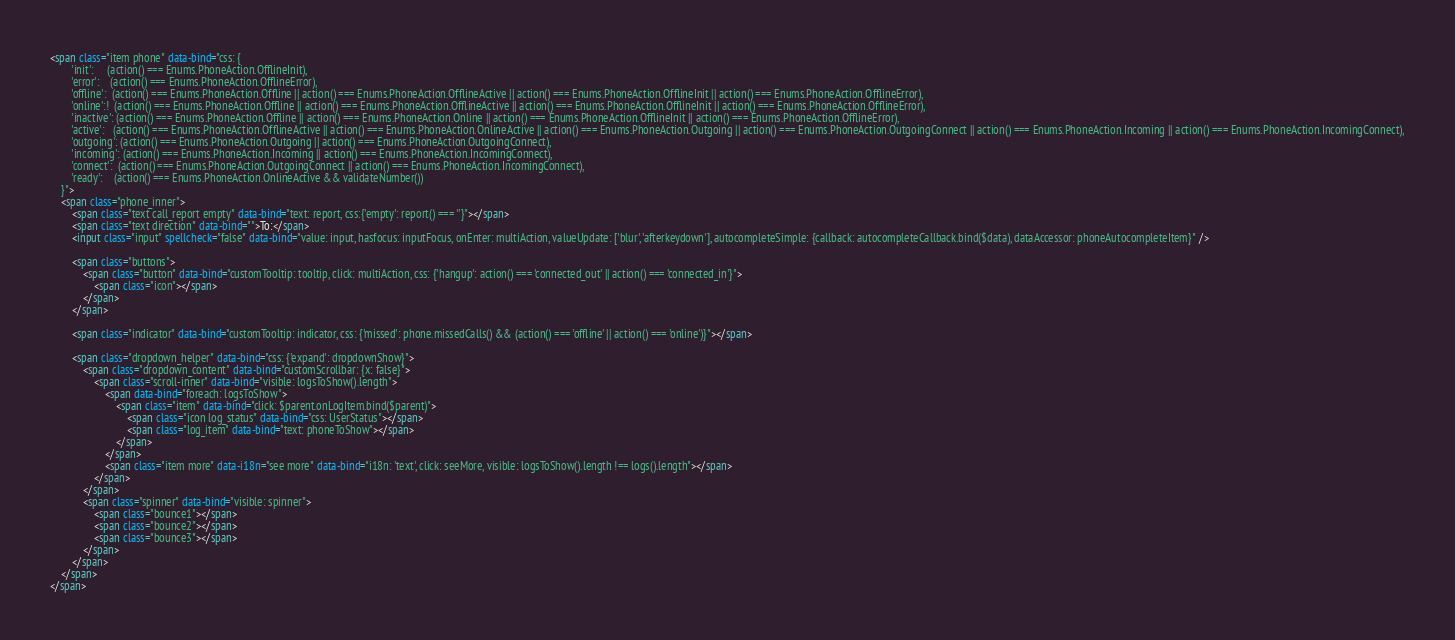<code> <loc_0><loc_0><loc_500><loc_500><_HTML_><span class="item phone" data-bind="css: {
		'init':		(action() === Enums.PhoneAction.OfflineInit),
		'error':	(action() === Enums.PhoneAction.OfflineError),
		'offline':	(action() === Enums.PhoneAction.Offline || action() === Enums.PhoneAction.OfflineActive || action() === Enums.PhoneAction.OfflineInit || action() === Enums.PhoneAction.OfflineError),
		'online':!	(action() === Enums.PhoneAction.Offline || action() === Enums.PhoneAction.OfflineActive || action() === Enums.PhoneAction.OfflineInit || action() === Enums.PhoneAction.OfflineError),
		'inactive':	(action() === Enums.PhoneAction.Offline || action() === Enums.PhoneAction.Online || action() === Enums.PhoneAction.OfflineInit || action() === Enums.PhoneAction.OfflineError),
		'active':	(action() === Enums.PhoneAction.OfflineActive || action() === Enums.PhoneAction.OnlineActive || action() === Enums.PhoneAction.Outgoing || action() === Enums.PhoneAction.OutgoingConnect || action() === Enums.PhoneAction.Incoming || action() === Enums.PhoneAction.IncomingConnect),
		'outgoing':	(action() === Enums.PhoneAction.Outgoing || action() === Enums.PhoneAction.OutgoingConnect),
		'incoming':	(action() === Enums.PhoneAction.Incoming || action() === Enums.PhoneAction.IncomingConnect),
		'connect':	(action() === Enums.PhoneAction.OutgoingConnect || action() === Enums.PhoneAction.IncomingConnect),
		'ready':	(action() === Enums.PhoneAction.OnlineActive && validateNumber())
	}">
	<span class="phone_inner">
		<span class="text call_report empty" data-bind="text: report, css:{'empty': report() === ''}"></span>
		<span class="text direction" data-bind="">To:</span>
		<input class="input" spellcheck="false" data-bind="value: input, hasfocus: inputFocus, onEnter: multiAction, valueUpdate: ['blur', 'afterkeydown'], autocompleteSimple: {callback: autocompleteCallback.bind($data), dataAccessor: phoneAutocompleteItem}" />

		<span class="buttons">
			<span class="button" data-bind="customTooltip: tooltip, click: multiAction, css: {'hangup': action() === 'connected_out' || action() === 'connected_in'}">
				<span class="icon"></span>
			</span>
		</span>

		<span class="indicator" data-bind="customTooltip: indicator, css: {'missed': phone.missedCalls() && (action() === 'offline' || action() === 'online')}"></span>

		<span class="dropdown_helper" data-bind="css: {'expand': dropdownShow}">
			<span class="dropdown_content" data-bind="customScrollbar: {x: false}">
				<span class="scroll-inner" data-bind="visible: logsToShow().length">
					<span data-bind="foreach: logsToShow">
						<span class="item" data-bind="click: $parent.onLogItem.bind($parent)">
							<span class="icon log_status" data-bind="css: UserStatus"></span>
							<span class="log_item" data-bind="text: phoneToShow"></span>
						</span>
					</span>
					<span class="item more" data-i18n="see more" data-bind="i18n: 'text', click: seeMore, visible: logsToShow().length !== logs().length"></span>
				</span>
			</span>
			<span class="spinner" data-bind="visible: spinner">
				<span class="bounce1"></span>
				<span class="bounce2"></span>
				<span class="bounce3"></span>
			</span>
		</span>
	</span>
</span></code> 